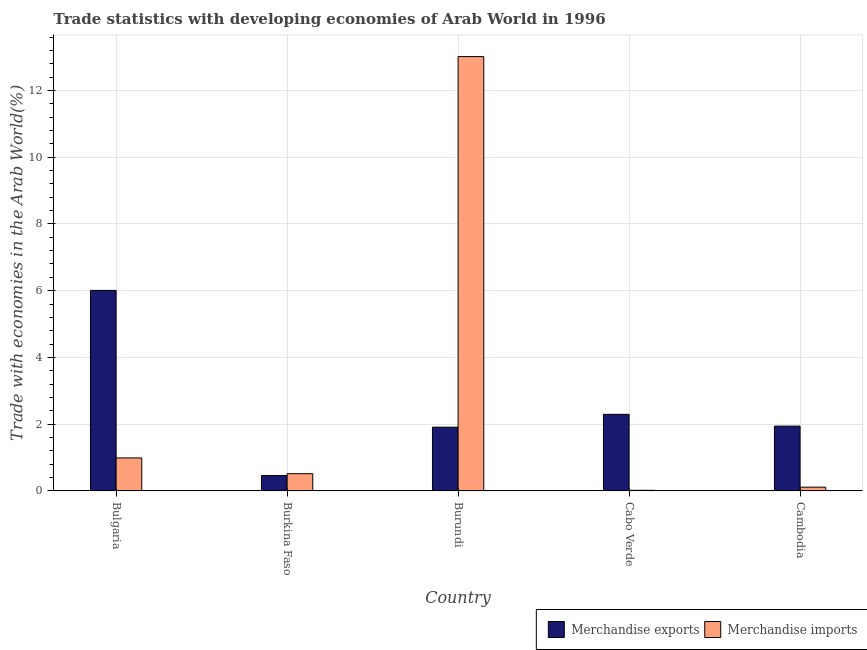How many different coloured bars are there?
Provide a succinct answer. 2. Are the number of bars on each tick of the X-axis equal?
Give a very brief answer. Yes. What is the label of the 1st group of bars from the left?
Give a very brief answer. Bulgaria. In how many cases, is the number of bars for a given country not equal to the number of legend labels?
Provide a succinct answer. 0. What is the merchandise imports in Cabo Verde?
Offer a terse response. 0.02. Across all countries, what is the maximum merchandise exports?
Keep it short and to the point. 6.01. Across all countries, what is the minimum merchandise imports?
Provide a short and direct response. 0.02. In which country was the merchandise imports maximum?
Provide a succinct answer. Burundi. In which country was the merchandise imports minimum?
Your response must be concise. Cabo Verde. What is the total merchandise exports in the graph?
Your answer should be very brief. 12.62. What is the difference between the merchandise exports in Cabo Verde and that in Cambodia?
Provide a succinct answer. 0.35. What is the difference between the merchandise exports in Burkina Faso and the merchandise imports in Burundi?
Offer a very short reply. -12.55. What is the average merchandise imports per country?
Your answer should be compact. 2.93. What is the difference between the merchandise exports and merchandise imports in Cambodia?
Your answer should be very brief. 1.83. What is the ratio of the merchandise exports in Burkina Faso to that in Cabo Verde?
Keep it short and to the point. 0.2. Is the merchandise exports in Bulgaria less than that in Burundi?
Ensure brevity in your answer.  No. What is the difference between the highest and the second highest merchandise imports?
Ensure brevity in your answer.  12.02. What is the difference between the highest and the lowest merchandise exports?
Offer a terse response. 5.55. Is the sum of the merchandise exports in Burkina Faso and Cambodia greater than the maximum merchandise imports across all countries?
Offer a terse response. No. Are all the bars in the graph horizontal?
Ensure brevity in your answer.  No. How many countries are there in the graph?
Offer a very short reply. 5. Does the graph contain any zero values?
Give a very brief answer. No. Where does the legend appear in the graph?
Your answer should be compact. Bottom right. What is the title of the graph?
Your answer should be very brief. Trade statistics with developing economies of Arab World in 1996. Does "Travel services" appear as one of the legend labels in the graph?
Give a very brief answer. No. What is the label or title of the Y-axis?
Your answer should be compact. Trade with economies in the Arab World(%). What is the Trade with economies in the Arab World(%) of Merchandise exports in Bulgaria?
Provide a succinct answer. 6.01. What is the Trade with economies in the Arab World(%) of Merchandise imports in Bulgaria?
Offer a terse response. 0.99. What is the Trade with economies in the Arab World(%) of Merchandise exports in Burkina Faso?
Offer a very short reply. 0.46. What is the Trade with economies in the Arab World(%) of Merchandise imports in Burkina Faso?
Make the answer very short. 0.52. What is the Trade with economies in the Arab World(%) in Merchandise exports in Burundi?
Provide a succinct answer. 1.91. What is the Trade with economies in the Arab World(%) in Merchandise imports in Burundi?
Give a very brief answer. 13.01. What is the Trade with economies in the Arab World(%) of Merchandise exports in Cabo Verde?
Offer a terse response. 2.3. What is the Trade with economies in the Arab World(%) in Merchandise imports in Cabo Verde?
Provide a short and direct response. 0.02. What is the Trade with economies in the Arab World(%) of Merchandise exports in Cambodia?
Provide a succinct answer. 1.94. What is the Trade with economies in the Arab World(%) of Merchandise imports in Cambodia?
Your response must be concise. 0.11. Across all countries, what is the maximum Trade with economies in the Arab World(%) in Merchandise exports?
Offer a very short reply. 6.01. Across all countries, what is the maximum Trade with economies in the Arab World(%) in Merchandise imports?
Make the answer very short. 13.01. Across all countries, what is the minimum Trade with economies in the Arab World(%) of Merchandise exports?
Provide a succinct answer. 0.46. Across all countries, what is the minimum Trade with economies in the Arab World(%) in Merchandise imports?
Ensure brevity in your answer.  0.02. What is the total Trade with economies in the Arab World(%) of Merchandise exports in the graph?
Give a very brief answer. 12.62. What is the total Trade with economies in the Arab World(%) in Merchandise imports in the graph?
Your response must be concise. 14.65. What is the difference between the Trade with economies in the Arab World(%) of Merchandise exports in Bulgaria and that in Burkina Faso?
Give a very brief answer. 5.55. What is the difference between the Trade with economies in the Arab World(%) of Merchandise imports in Bulgaria and that in Burkina Faso?
Offer a terse response. 0.47. What is the difference between the Trade with economies in the Arab World(%) in Merchandise exports in Bulgaria and that in Burundi?
Ensure brevity in your answer.  4.1. What is the difference between the Trade with economies in the Arab World(%) in Merchandise imports in Bulgaria and that in Burundi?
Offer a terse response. -12.03. What is the difference between the Trade with economies in the Arab World(%) of Merchandise exports in Bulgaria and that in Cabo Verde?
Your answer should be very brief. 3.71. What is the difference between the Trade with economies in the Arab World(%) in Merchandise imports in Bulgaria and that in Cabo Verde?
Ensure brevity in your answer.  0.97. What is the difference between the Trade with economies in the Arab World(%) of Merchandise exports in Bulgaria and that in Cambodia?
Keep it short and to the point. 4.07. What is the difference between the Trade with economies in the Arab World(%) of Merchandise imports in Bulgaria and that in Cambodia?
Provide a short and direct response. 0.88. What is the difference between the Trade with economies in the Arab World(%) of Merchandise exports in Burkina Faso and that in Burundi?
Make the answer very short. -1.45. What is the difference between the Trade with economies in the Arab World(%) of Merchandise imports in Burkina Faso and that in Burundi?
Give a very brief answer. -12.5. What is the difference between the Trade with economies in the Arab World(%) in Merchandise exports in Burkina Faso and that in Cabo Verde?
Make the answer very short. -1.83. What is the difference between the Trade with economies in the Arab World(%) of Merchandise imports in Burkina Faso and that in Cabo Verde?
Keep it short and to the point. 0.5. What is the difference between the Trade with economies in the Arab World(%) in Merchandise exports in Burkina Faso and that in Cambodia?
Provide a succinct answer. -1.48. What is the difference between the Trade with economies in the Arab World(%) of Merchandise imports in Burkina Faso and that in Cambodia?
Keep it short and to the point. 0.4. What is the difference between the Trade with economies in the Arab World(%) of Merchandise exports in Burundi and that in Cabo Verde?
Provide a short and direct response. -0.38. What is the difference between the Trade with economies in the Arab World(%) in Merchandise imports in Burundi and that in Cabo Verde?
Offer a very short reply. 12.99. What is the difference between the Trade with economies in the Arab World(%) of Merchandise exports in Burundi and that in Cambodia?
Ensure brevity in your answer.  -0.03. What is the difference between the Trade with economies in the Arab World(%) in Merchandise imports in Burundi and that in Cambodia?
Your answer should be very brief. 12.9. What is the difference between the Trade with economies in the Arab World(%) of Merchandise exports in Cabo Verde and that in Cambodia?
Ensure brevity in your answer.  0.35. What is the difference between the Trade with economies in the Arab World(%) in Merchandise imports in Cabo Verde and that in Cambodia?
Give a very brief answer. -0.09. What is the difference between the Trade with economies in the Arab World(%) in Merchandise exports in Bulgaria and the Trade with economies in the Arab World(%) in Merchandise imports in Burkina Faso?
Keep it short and to the point. 5.49. What is the difference between the Trade with economies in the Arab World(%) of Merchandise exports in Bulgaria and the Trade with economies in the Arab World(%) of Merchandise imports in Burundi?
Make the answer very short. -7.01. What is the difference between the Trade with economies in the Arab World(%) in Merchandise exports in Bulgaria and the Trade with economies in the Arab World(%) in Merchandise imports in Cabo Verde?
Your answer should be compact. 5.99. What is the difference between the Trade with economies in the Arab World(%) of Merchandise exports in Bulgaria and the Trade with economies in the Arab World(%) of Merchandise imports in Cambodia?
Give a very brief answer. 5.9. What is the difference between the Trade with economies in the Arab World(%) of Merchandise exports in Burkina Faso and the Trade with economies in the Arab World(%) of Merchandise imports in Burundi?
Make the answer very short. -12.55. What is the difference between the Trade with economies in the Arab World(%) in Merchandise exports in Burkina Faso and the Trade with economies in the Arab World(%) in Merchandise imports in Cabo Verde?
Give a very brief answer. 0.44. What is the difference between the Trade with economies in the Arab World(%) of Merchandise exports in Burkina Faso and the Trade with economies in the Arab World(%) of Merchandise imports in Cambodia?
Offer a very short reply. 0.35. What is the difference between the Trade with economies in the Arab World(%) in Merchandise exports in Burundi and the Trade with economies in the Arab World(%) in Merchandise imports in Cabo Verde?
Give a very brief answer. 1.89. What is the difference between the Trade with economies in the Arab World(%) of Merchandise exports in Burundi and the Trade with economies in the Arab World(%) of Merchandise imports in Cambodia?
Ensure brevity in your answer.  1.8. What is the difference between the Trade with economies in the Arab World(%) of Merchandise exports in Cabo Verde and the Trade with economies in the Arab World(%) of Merchandise imports in Cambodia?
Your answer should be very brief. 2.18. What is the average Trade with economies in the Arab World(%) of Merchandise exports per country?
Provide a short and direct response. 2.52. What is the average Trade with economies in the Arab World(%) of Merchandise imports per country?
Your answer should be very brief. 2.93. What is the difference between the Trade with economies in the Arab World(%) of Merchandise exports and Trade with economies in the Arab World(%) of Merchandise imports in Bulgaria?
Give a very brief answer. 5.02. What is the difference between the Trade with economies in the Arab World(%) in Merchandise exports and Trade with economies in the Arab World(%) in Merchandise imports in Burkina Faso?
Ensure brevity in your answer.  -0.06. What is the difference between the Trade with economies in the Arab World(%) in Merchandise exports and Trade with economies in the Arab World(%) in Merchandise imports in Burundi?
Provide a short and direct response. -11.1. What is the difference between the Trade with economies in the Arab World(%) in Merchandise exports and Trade with economies in the Arab World(%) in Merchandise imports in Cabo Verde?
Your response must be concise. 2.28. What is the difference between the Trade with economies in the Arab World(%) of Merchandise exports and Trade with economies in the Arab World(%) of Merchandise imports in Cambodia?
Provide a short and direct response. 1.83. What is the ratio of the Trade with economies in the Arab World(%) of Merchandise exports in Bulgaria to that in Burkina Faso?
Provide a short and direct response. 13.03. What is the ratio of the Trade with economies in the Arab World(%) of Merchandise imports in Bulgaria to that in Burkina Faso?
Give a very brief answer. 1.91. What is the ratio of the Trade with economies in the Arab World(%) of Merchandise exports in Bulgaria to that in Burundi?
Your response must be concise. 3.14. What is the ratio of the Trade with economies in the Arab World(%) in Merchandise imports in Bulgaria to that in Burundi?
Your response must be concise. 0.08. What is the ratio of the Trade with economies in the Arab World(%) in Merchandise exports in Bulgaria to that in Cabo Verde?
Make the answer very short. 2.62. What is the ratio of the Trade with economies in the Arab World(%) of Merchandise imports in Bulgaria to that in Cabo Verde?
Your answer should be compact. 52.06. What is the ratio of the Trade with economies in the Arab World(%) in Merchandise exports in Bulgaria to that in Cambodia?
Your answer should be very brief. 3.09. What is the ratio of the Trade with economies in the Arab World(%) in Merchandise imports in Bulgaria to that in Cambodia?
Ensure brevity in your answer.  8.72. What is the ratio of the Trade with economies in the Arab World(%) in Merchandise exports in Burkina Faso to that in Burundi?
Give a very brief answer. 0.24. What is the ratio of the Trade with economies in the Arab World(%) in Merchandise imports in Burkina Faso to that in Burundi?
Ensure brevity in your answer.  0.04. What is the ratio of the Trade with economies in the Arab World(%) in Merchandise exports in Burkina Faso to that in Cabo Verde?
Offer a terse response. 0.2. What is the ratio of the Trade with economies in the Arab World(%) in Merchandise imports in Burkina Faso to that in Cabo Verde?
Make the answer very short. 27.22. What is the ratio of the Trade with economies in the Arab World(%) in Merchandise exports in Burkina Faso to that in Cambodia?
Ensure brevity in your answer.  0.24. What is the ratio of the Trade with economies in the Arab World(%) of Merchandise imports in Burkina Faso to that in Cambodia?
Your answer should be compact. 4.56. What is the ratio of the Trade with economies in the Arab World(%) in Merchandise exports in Burundi to that in Cabo Verde?
Offer a terse response. 0.83. What is the ratio of the Trade with economies in the Arab World(%) of Merchandise imports in Burundi to that in Cabo Verde?
Offer a very short reply. 685.06. What is the ratio of the Trade with economies in the Arab World(%) in Merchandise exports in Burundi to that in Cambodia?
Keep it short and to the point. 0.98. What is the ratio of the Trade with economies in the Arab World(%) in Merchandise imports in Burundi to that in Cambodia?
Make the answer very short. 114.75. What is the ratio of the Trade with economies in the Arab World(%) in Merchandise exports in Cabo Verde to that in Cambodia?
Your answer should be very brief. 1.18. What is the ratio of the Trade with economies in the Arab World(%) in Merchandise imports in Cabo Verde to that in Cambodia?
Ensure brevity in your answer.  0.17. What is the difference between the highest and the second highest Trade with economies in the Arab World(%) in Merchandise exports?
Keep it short and to the point. 3.71. What is the difference between the highest and the second highest Trade with economies in the Arab World(%) in Merchandise imports?
Make the answer very short. 12.03. What is the difference between the highest and the lowest Trade with economies in the Arab World(%) of Merchandise exports?
Offer a terse response. 5.55. What is the difference between the highest and the lowest Trade with economies in the Arab World(%) of Merchandise imports?
Your answer should be compact. 12.99. 